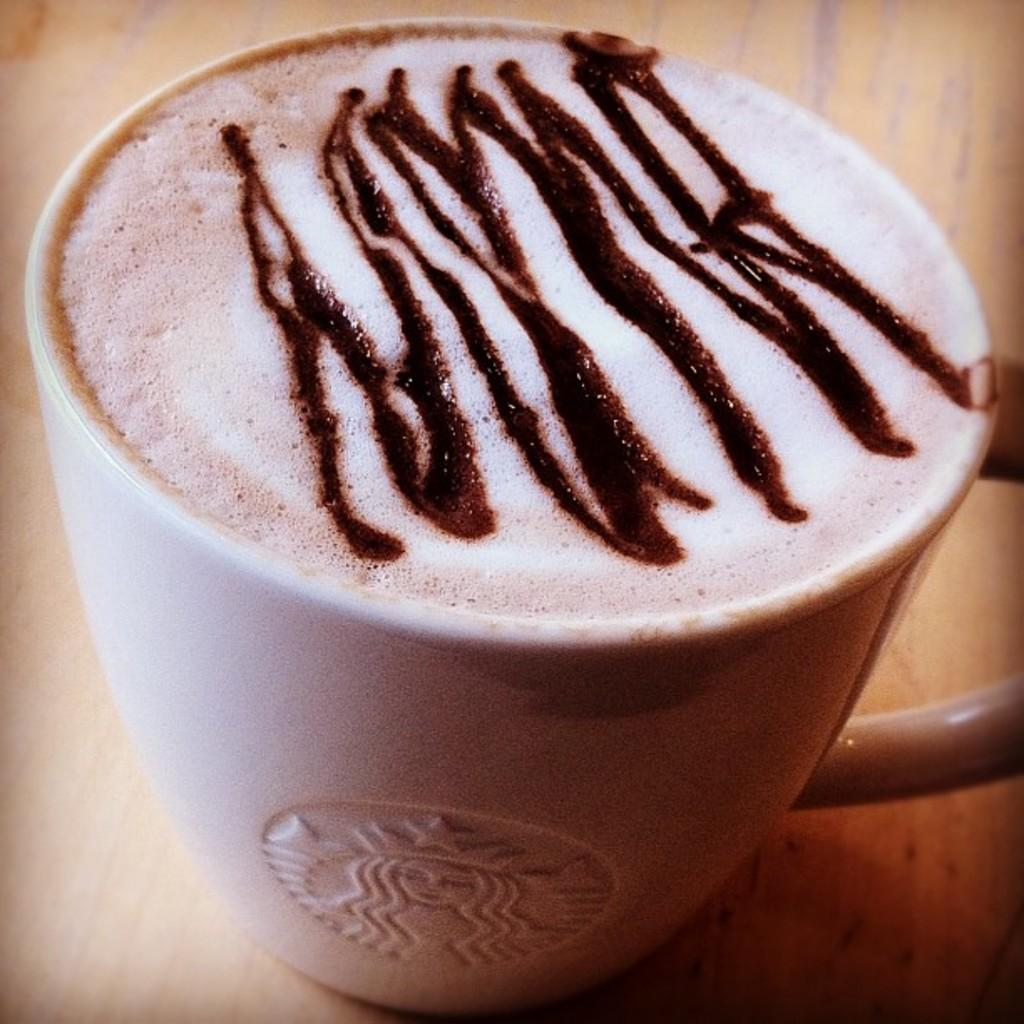What is in the mug that is visible in the image? The mug contains coffee. Where is the mug located in the image? The mug is on a table. What might be used to drink the coffee in the mug? The mug is likely used for drinking coffee. What type of plastic is used to create the territory in the image? There is no territory or plastic present in the image; it features a mug with coffee on a table. 